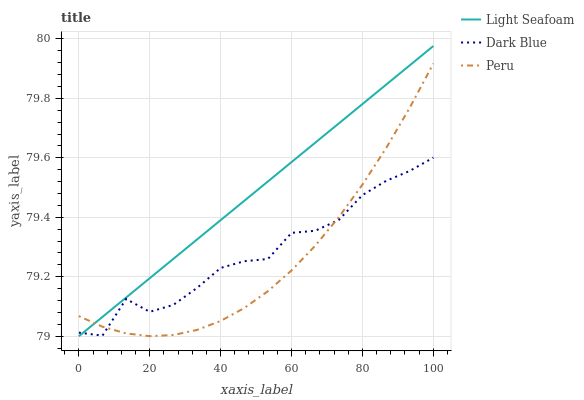Does Peru have the minimum area under the curve?
Answer yes or no. Yes. Does Light Seafoam have the maximum area under the curve?
Answer yes or no. Yes. Does Light Seafoam have the minimum area under the curve?
Answer yes or no. No. Does Peru have the maximum area under the curve?
Answer yes or no. No. Is Light Seafoam the smoothest?
Answer yes or no. Yes. Is Dark Blue the roughest?
Answer yes or no. Yes. Is Peru the smoothest?
Answer yes or no. No. Is Peru the roughest?
Answer yes or no. No. Does Light Seafoam have the lowest value?
Answer yes or no. Yes. Does Peru have the lowest value?
Answer yes or no. No. Does Light Seafoam have the highest value?
Answer yes or no. Yes. Does Peru have the highest value?
Answer yes or no. No. Does Dark Blue intersect Peru?
Answer yes or no. Yes. Is Dark Blue less than Peru?
Answer yes or no. No. Is Dark Blue greater than Peru?
Answer yes or no. No. 